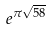Convert formula to latex. <formula><loc_0><loc_0><loc_500><loc_500>e ^ { \pi \sqrt { 5 8 } }</formula> 